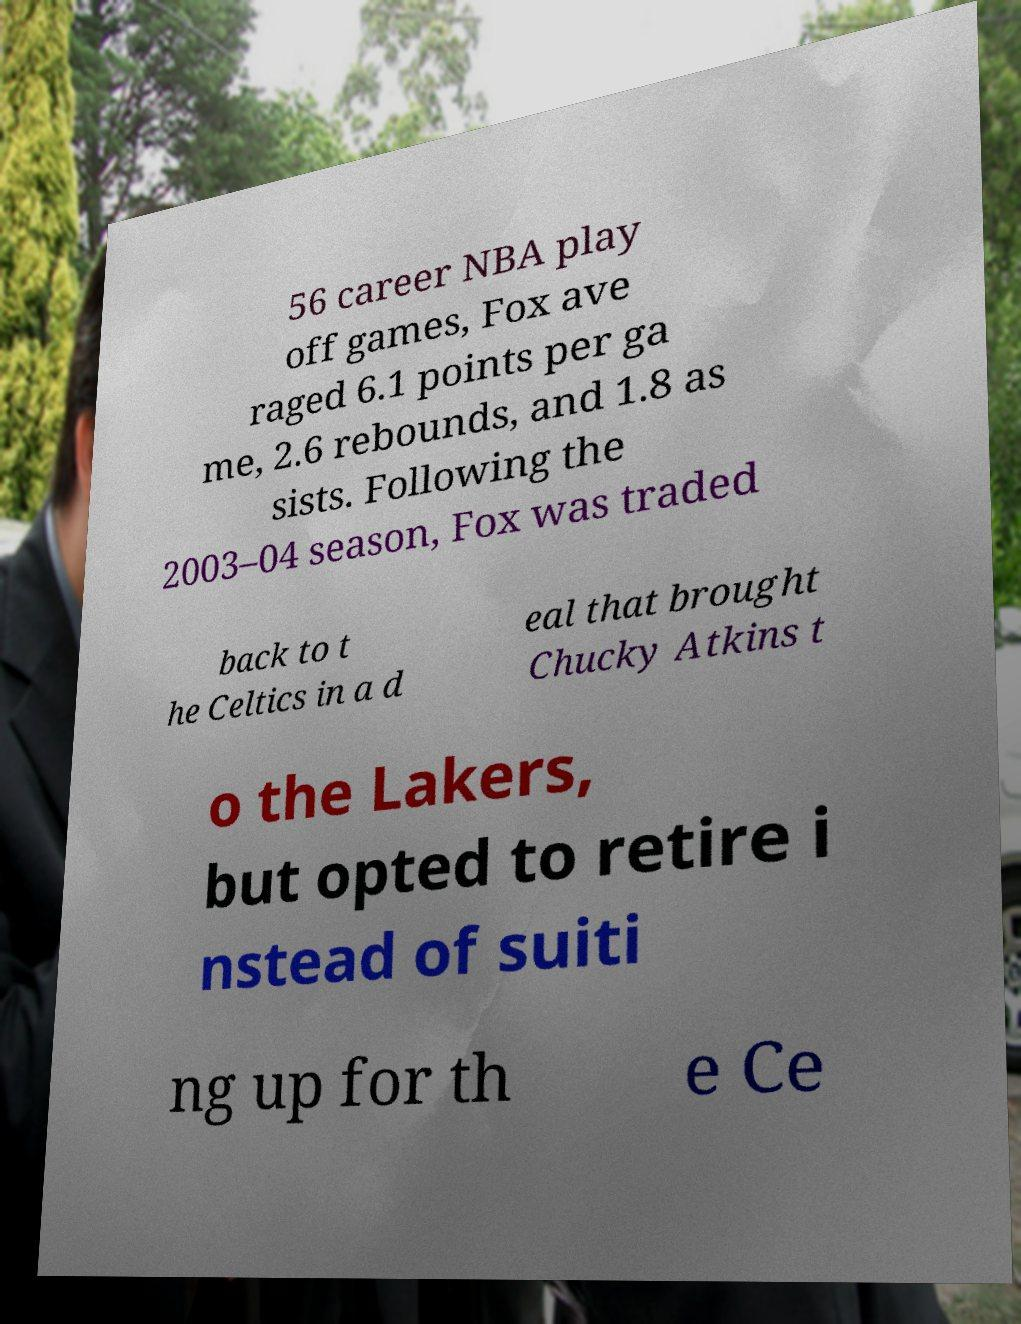I need the written content from this picture converted into text. Can you do that? 56 career NBA play off games, Fox ave raged 6.1 points per ga me, 2.6 rebounds, and 1.8 as sists. Following the 2003–04 season, Fox was traded back to t he Celtics in a d eal that brought Chucky Atkins t o the Lakers, but opted to retire i nstead of suiti ng up for th e Ce 